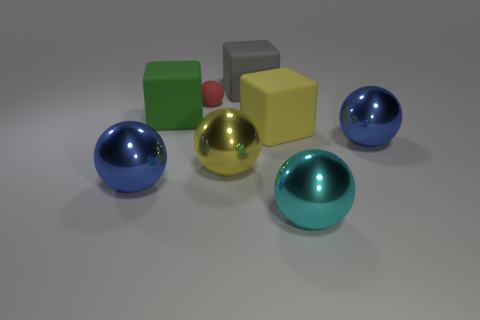There is a yellow matte cube; how many blue spheres are on the left side of it?
Offer a terse response. 1. What number of objects are either big green rubber spheres or large cyan shiny spheres?
Make the answer very short. 1. What number of yellow blocks have the same size as the yellow ball?
Your response must be concise. 1. What shape is the large yellow matte thing that is to the right of the large metal sphere to the left of the red rubber sphere?
Offer a terse response. Cube. Are there fewer yellow matte cubes than small purple cylinders?
Your answer should be very brief. No. There is a ball that is behind the big yellow block; what color is it?
Offer a terse response. Red. There is a big thing that is both in front of the yellow sphere and right of the big green rubber object; what material is it?
Provide a short and direct response. Metal. The yellow object that is made of the same material as the cyan ball is what shape?
Make the answer very short. Sphere. There is a yellow rubber block in front of the green matte thing; what number of big cubes are behind it?
Provide a short and direct response. 2. How many rubber blocks are in front of the tiny rubber ball and on the right side of the yellow shiny sphere?
Ensure brevity in your answer.  1. 